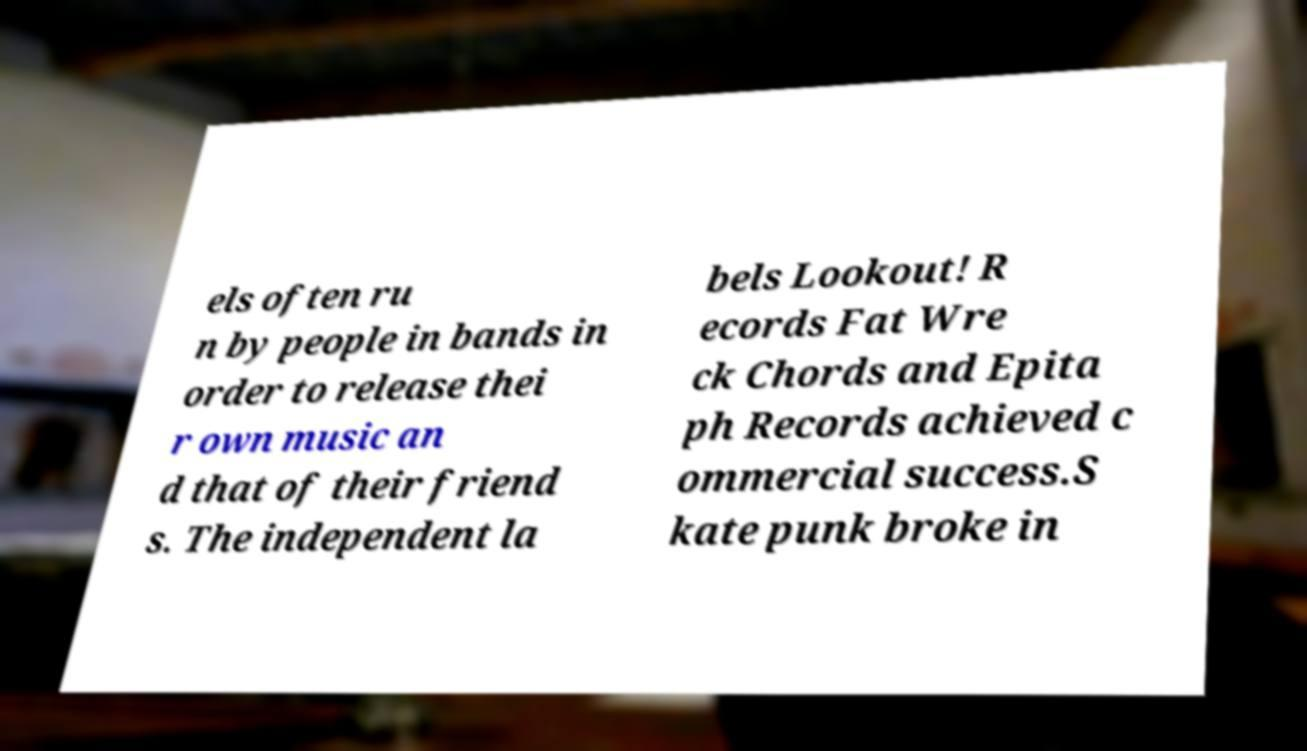What messages or text are displayed in this image? I need them in a readable, typed format. els often ru n by people in bands in order to release thei r own music an d that of their friend s. The independent la bels Lookout! R ecords Fat Wre ck Chords and Epita ph Records achieved c ommercial success.S kate punk broke in 